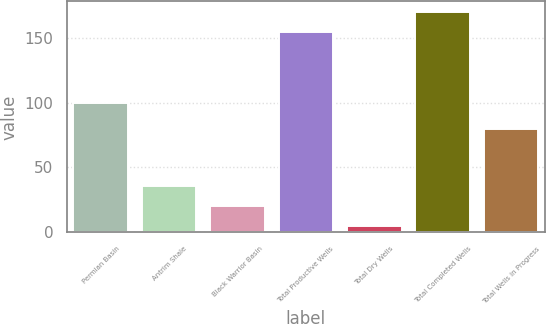Convert chart. <chart><loc_0><loc_0><loc_500><loc_500><bar_chart><fcel>Permian Basin<fcel>Antrim Shale<fcel>Black Warrior Basin<fcel>Total Productive Wells<fcel>Total Dry Wells<fcel>Total Completed Wells<fcel>Total Wells in Progress<nl><fcel>100<fcel>35.8<fcel>20.4<fcel>154<fcel>5<fcel>169.4<fcel>80<nl></chart> 